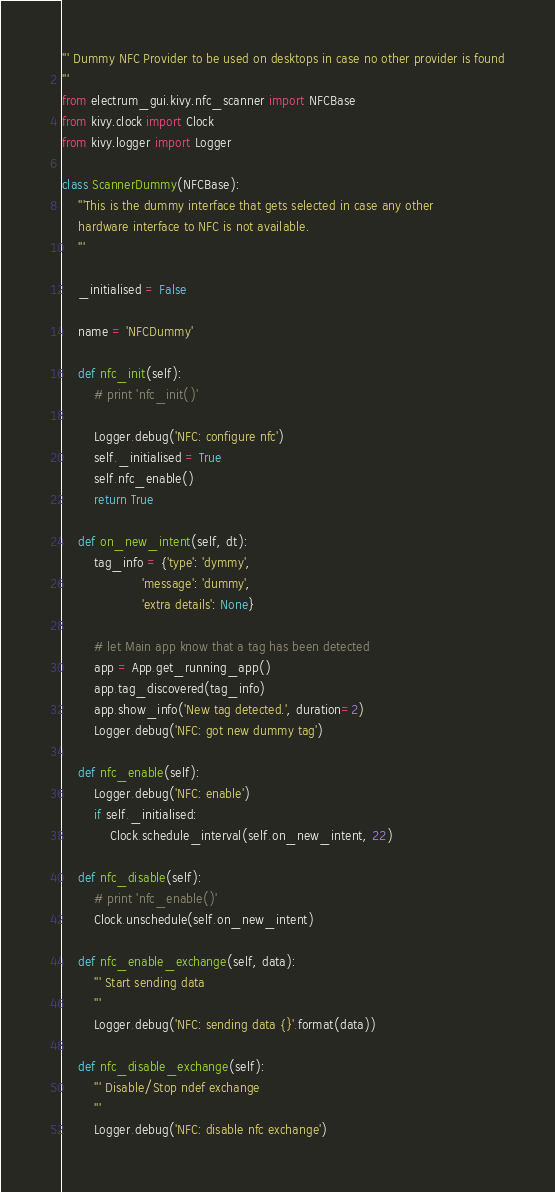Convert code to text. <code><loc_0><loc_0><loc_500><loc_500><_Python_>''' Dummy NFC Provider to be used on desktops in case no other provider is found
'''
from electrum_gui.kivy.nfc_scanner import NFCBase
from kivy.clock import Clock
from kivy.logger import Logger

class ScannerDummy(NFCBase):
    '''This is the dummy interface that gets selected in case any other
    hardware interface to NFC is not available.
    '''

    _initialised = False

    name = 'NFCDummy'

    def nfc_init(self):
        # print 'nfc_init()'

        Logger.debug('NFC: configure nfc')
        self._initialised = True
        self.nfc_enable()
        return True

    def on_new_intent(self, dt):
        tag_info = {'type': 'dymmy',
                    'message': 'dummy',
                    'extra details': None}

        # let Main app know that a tag has been detected
        app = App.get_running_app()
        app.tag_discovered(tag_info)
        app.show_info('New tag detected.', duration=2)
        Logger.debug('NFC: got new dummy tag')

    def nfc_enable(self):
        Logger.debug('NFC: enable')
        if self._initialised:
            Clock.schedule_interval(self.on_new_intent, 22)

    def nfc_disable(self):
        # print 'nfc_enable()'
        Clock.unschedule(self.on_new_intent)

    def nfc_enable_exchange(self, data):
        ''' Start sending data
        '''
        Logger.debug('NFC: sending data {}'.format(data))

    def nfc_disable_exchange(self):
        ''' Disable/Stop ndef exchange
        '''
        Logger.debug('NFC: disable nfc exchange')
</code> 